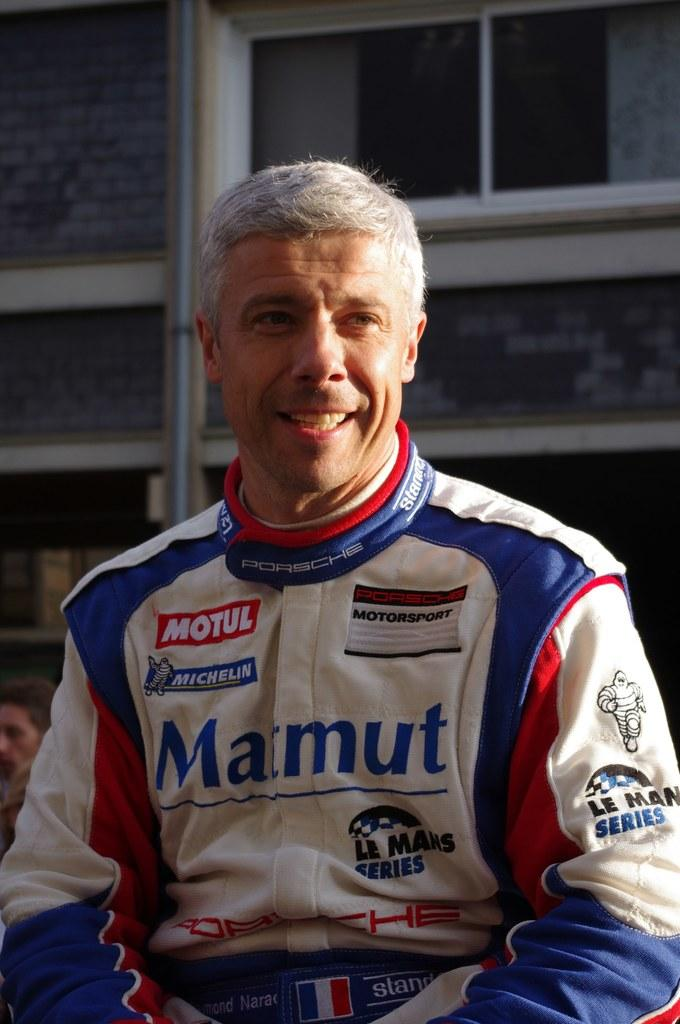<image>
Give a short and clear explanation of the subsequent image. The race car driver in the picture has Matnut as a sponsor. 